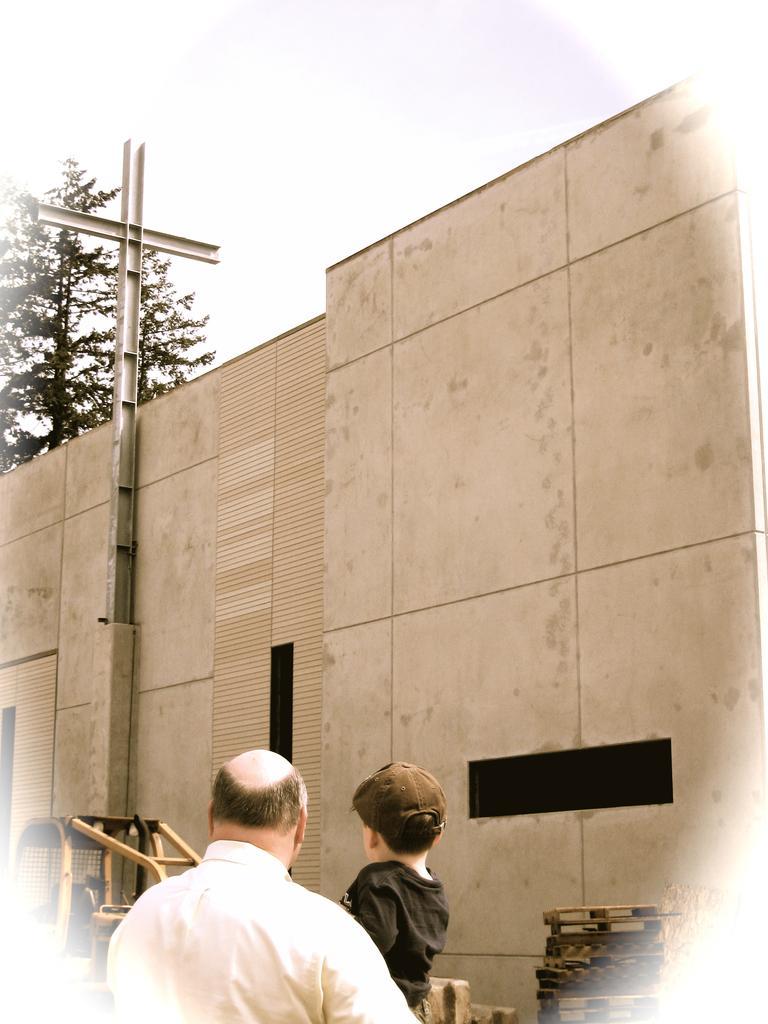Describe this image in one or two sentences. In this image I can see a man and a boy. I can see he is wearing white colour dress and he is wearing black. In the background I can see a wall, few things and a tree. 